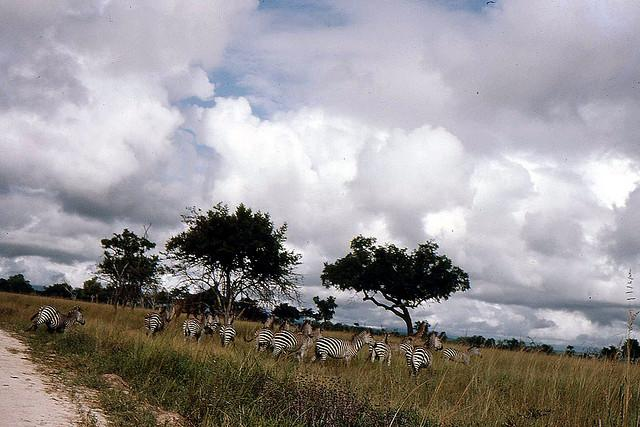The clouds in the sky depict that a is coming?

Choices:
A) earthquake
B) hurricane
C) snowstorm
D) storm storm 